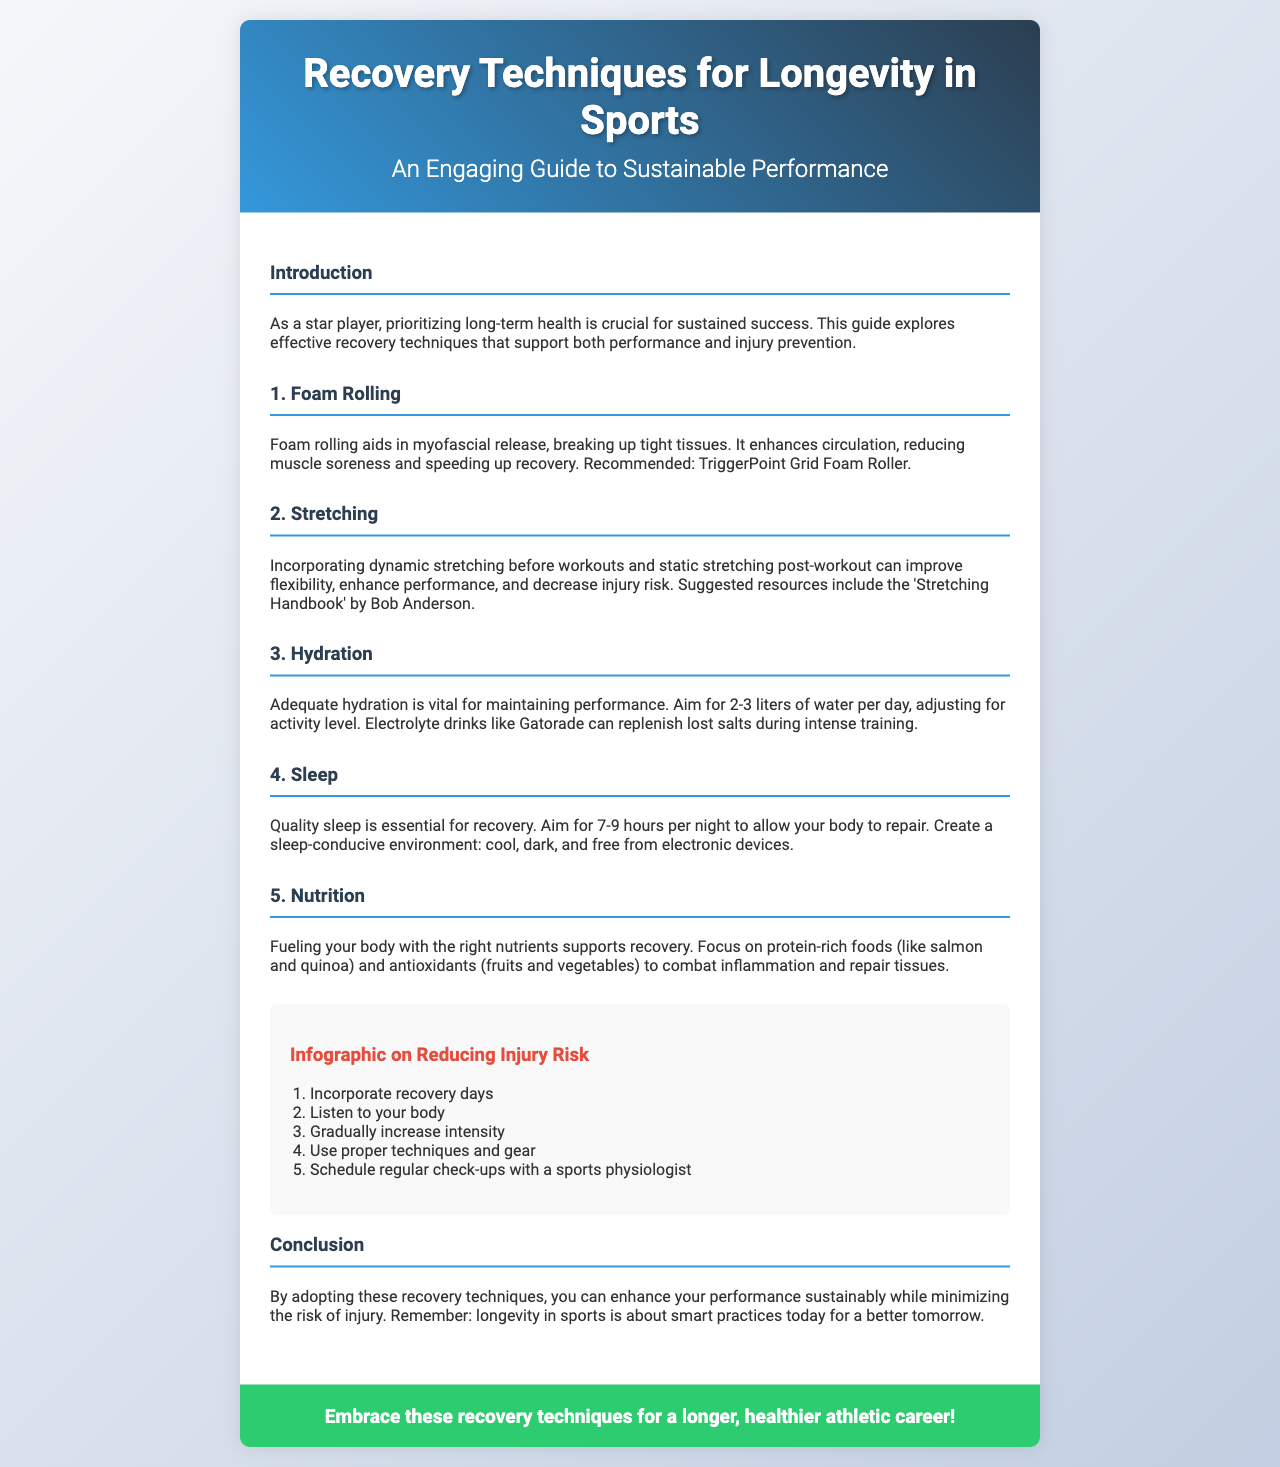what is the title of the brochure? The title of the brochure is presented in the header section.
Answer: Recovery Techniques for Longevity in Sports how many sections are in the content? The number of sections refers to the distinct parts of the content area.
Answer: 6 what does foam rolling aid in? Foam rolling's benefits are outlined in the section discussing it.
Answer: Myofascial release how many liters of water should an athlete aim for daily? The specific amount of water recommended is mentioned in the hydration section.
Answer: 2-3 liters what is emphasized as essential for recovery? The introduction highlights the importance of a specific factor for recovery and performance.
Answer: Quality sleep name one type of food to focus on for nutrition. The nutrition section lists foods that support recovery and health.
Answer: Protein-rich foods which recovery technique should be incorporated regularly? The infographic section lists important practices for injury risk reduction.
Answer: Recovery days what is the suggested resource for stretching? The stretching section recommends a specific guide under resources.
Answer: 'Stretching Handbook' by Bob Anderson how many hours of sleep should an athlete aim for? The recommended hours of sleep are clearly stated in the sleep section.
Answer: 7-9 hours 